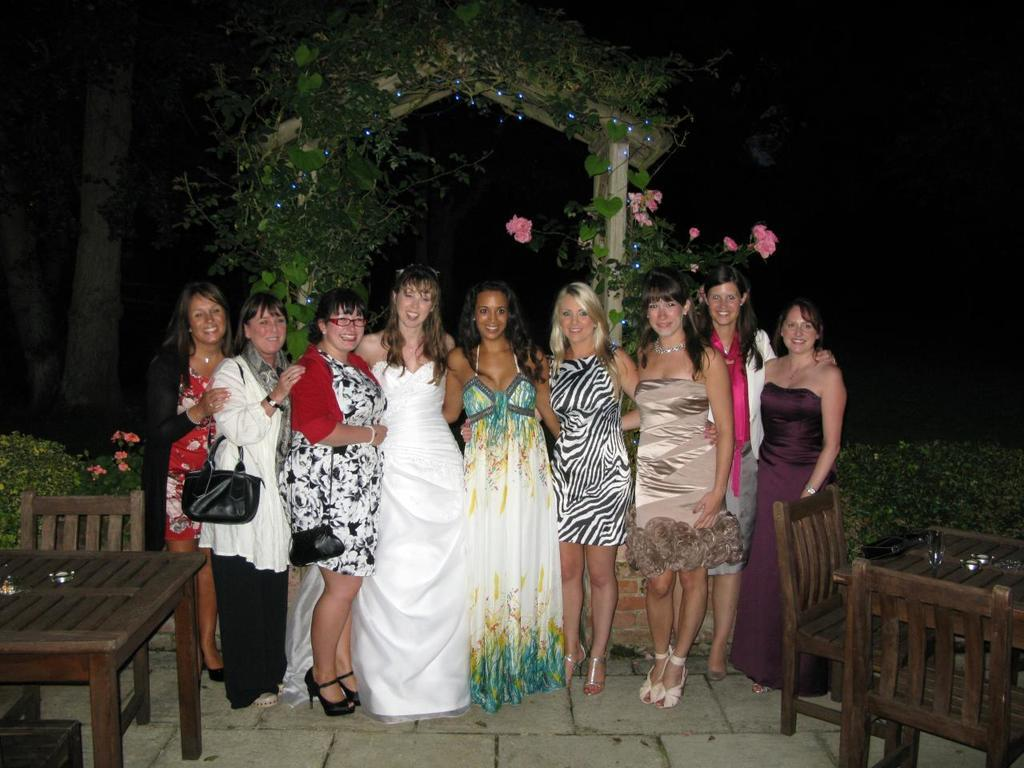What is the main subject of the image? The main subject of the image is a group of lady persons. What are the lady persons doing in the image? The lady persons are standing on the floor. What can be seen in the background of the image? There are trees in the background of the image. What type of baseball equipment can be seen in the image? There is no baseball equipment present in the image. Is the ground covered in snow in the image? There is no snow visible in the image; the lady persons are standing on the floor. 